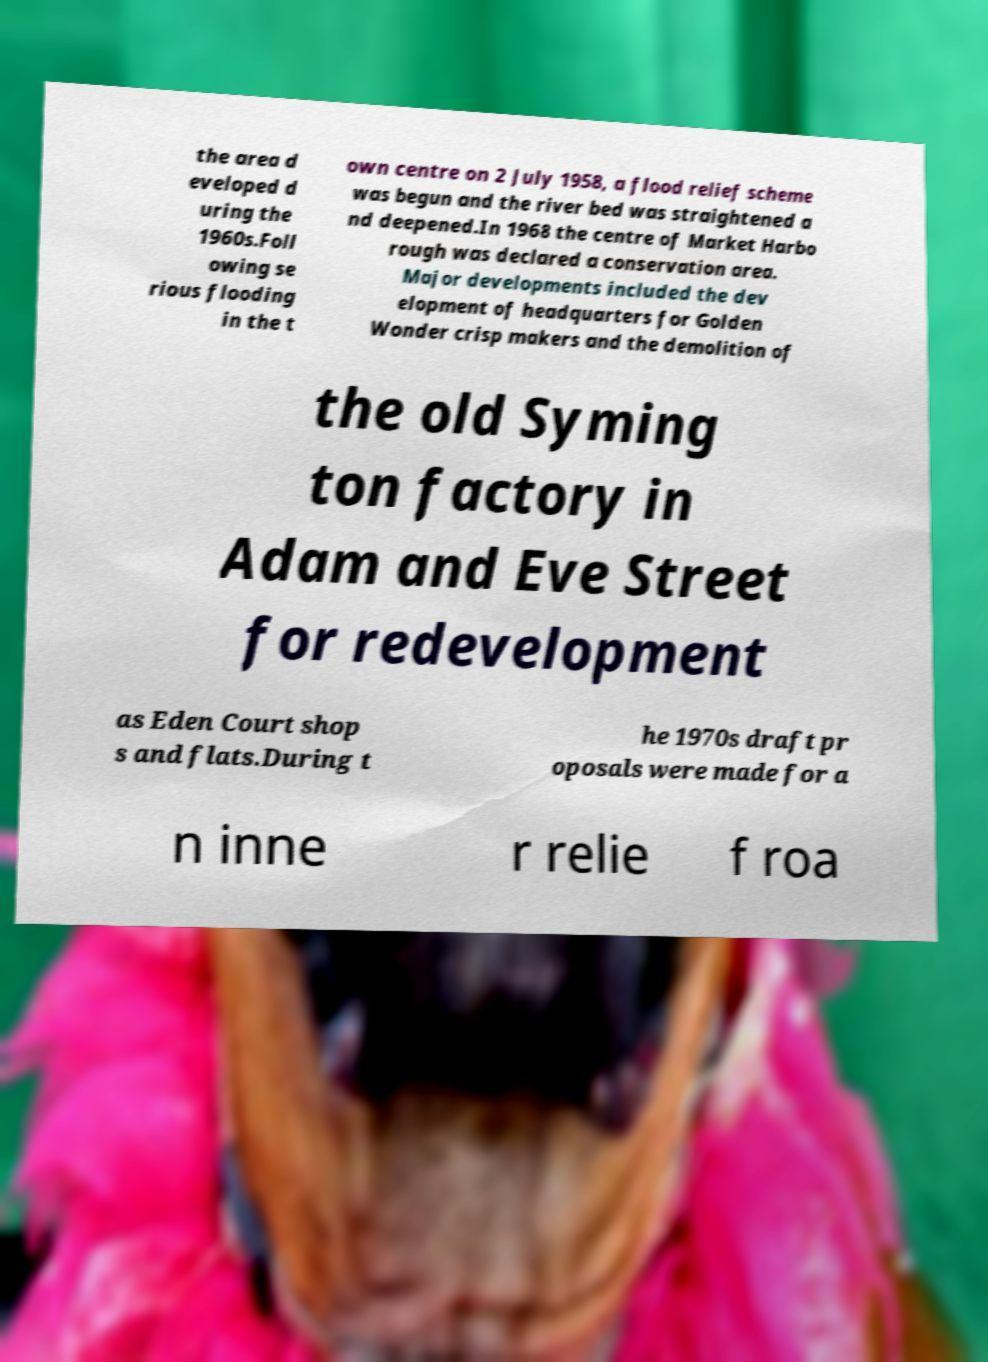I need the written content from this picture converted into text. Can you do that? the area d eveloped d uring the 1960s.Foll owing se rious flooding in the t own centre on 2 July 1958, a flood relief scheme was begun and the river bed was straightened a nd deepened.In 1968 the centre of Market Harbo rough was declared a conservation area. Major developments included the dev elopment of headquarters for Golden Wonder crisp makers and the demolition of the old Syming ton factory in Adam and Eve Street for redevelopment as Eden Court shop s and flats.During t he 1970s draft pr oposals were made for a n inne r relie f roa 